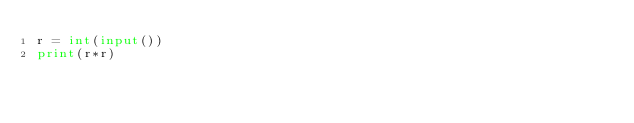Convert code to text. <code><loc_0><loc_0><loc_500><loc_500><_Python_>r = int(input())
print(r*r)</code> 